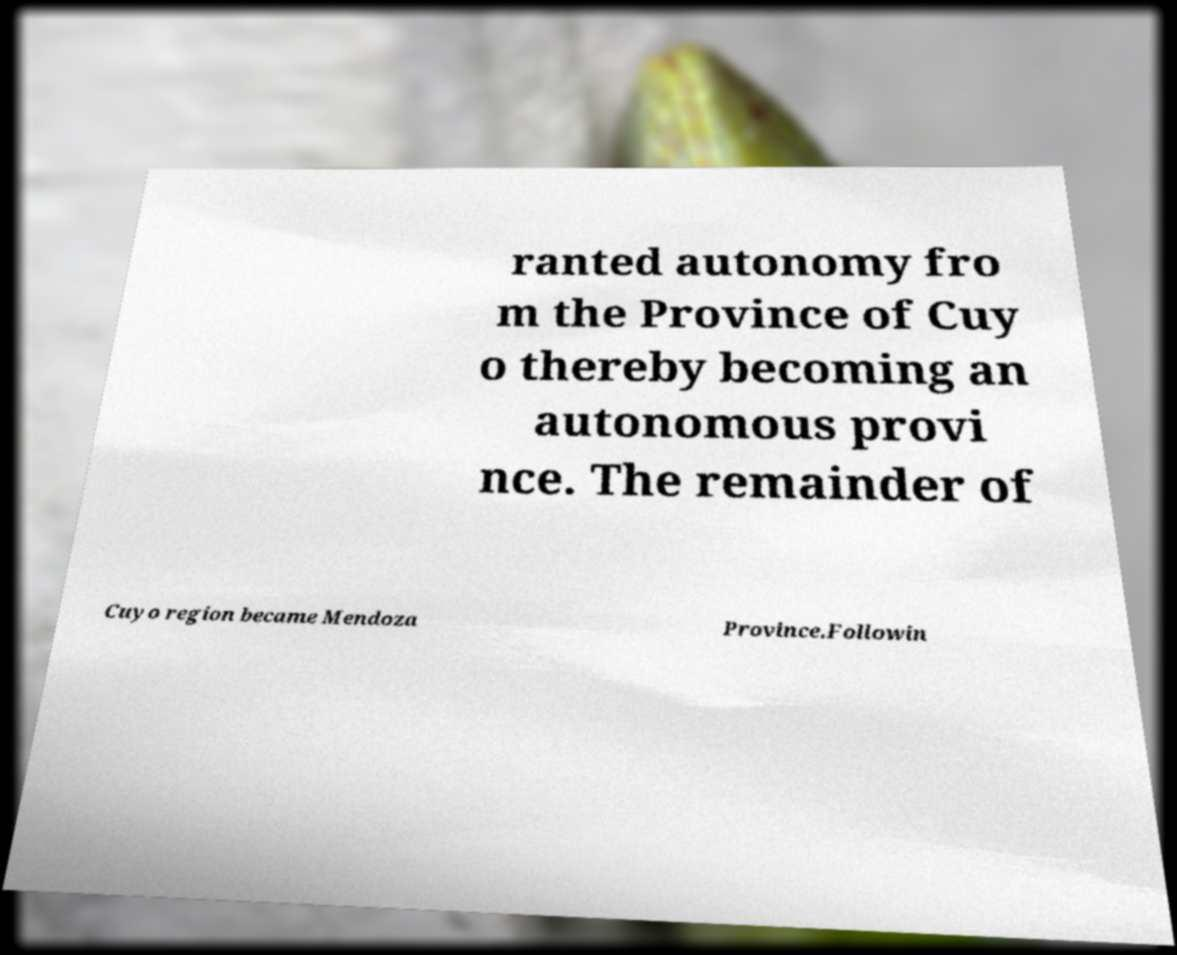Please read and relay the text visible in this image. What does it say? ranted autonomy fro m the Province of Cuy o thereby becoming an autonomous provi nce. The remainder of Cuyo region became Mendoza Province.Followin 